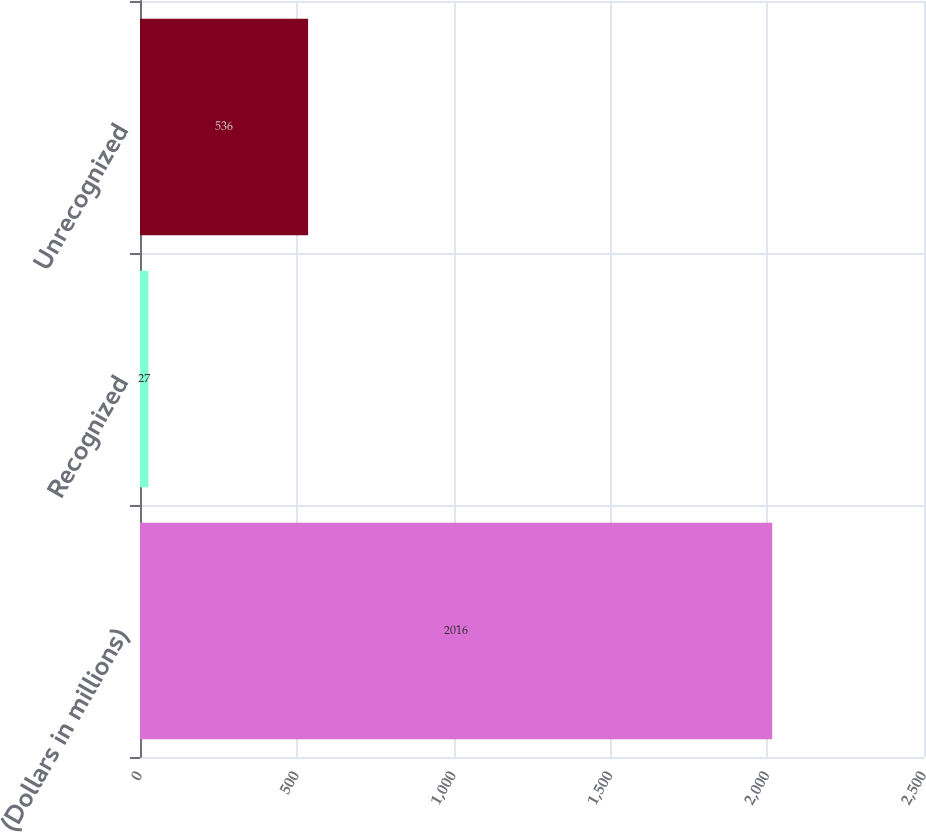Convert chart. <chart><loc_0><loc_0><loc_500><loc_500><bar_chart><fcel>(Dollars in millions)<fcel>Recognized<fcel>Unrecognized<nl><fcel>2016<fcel>27<fcel>536<nl></chart> 